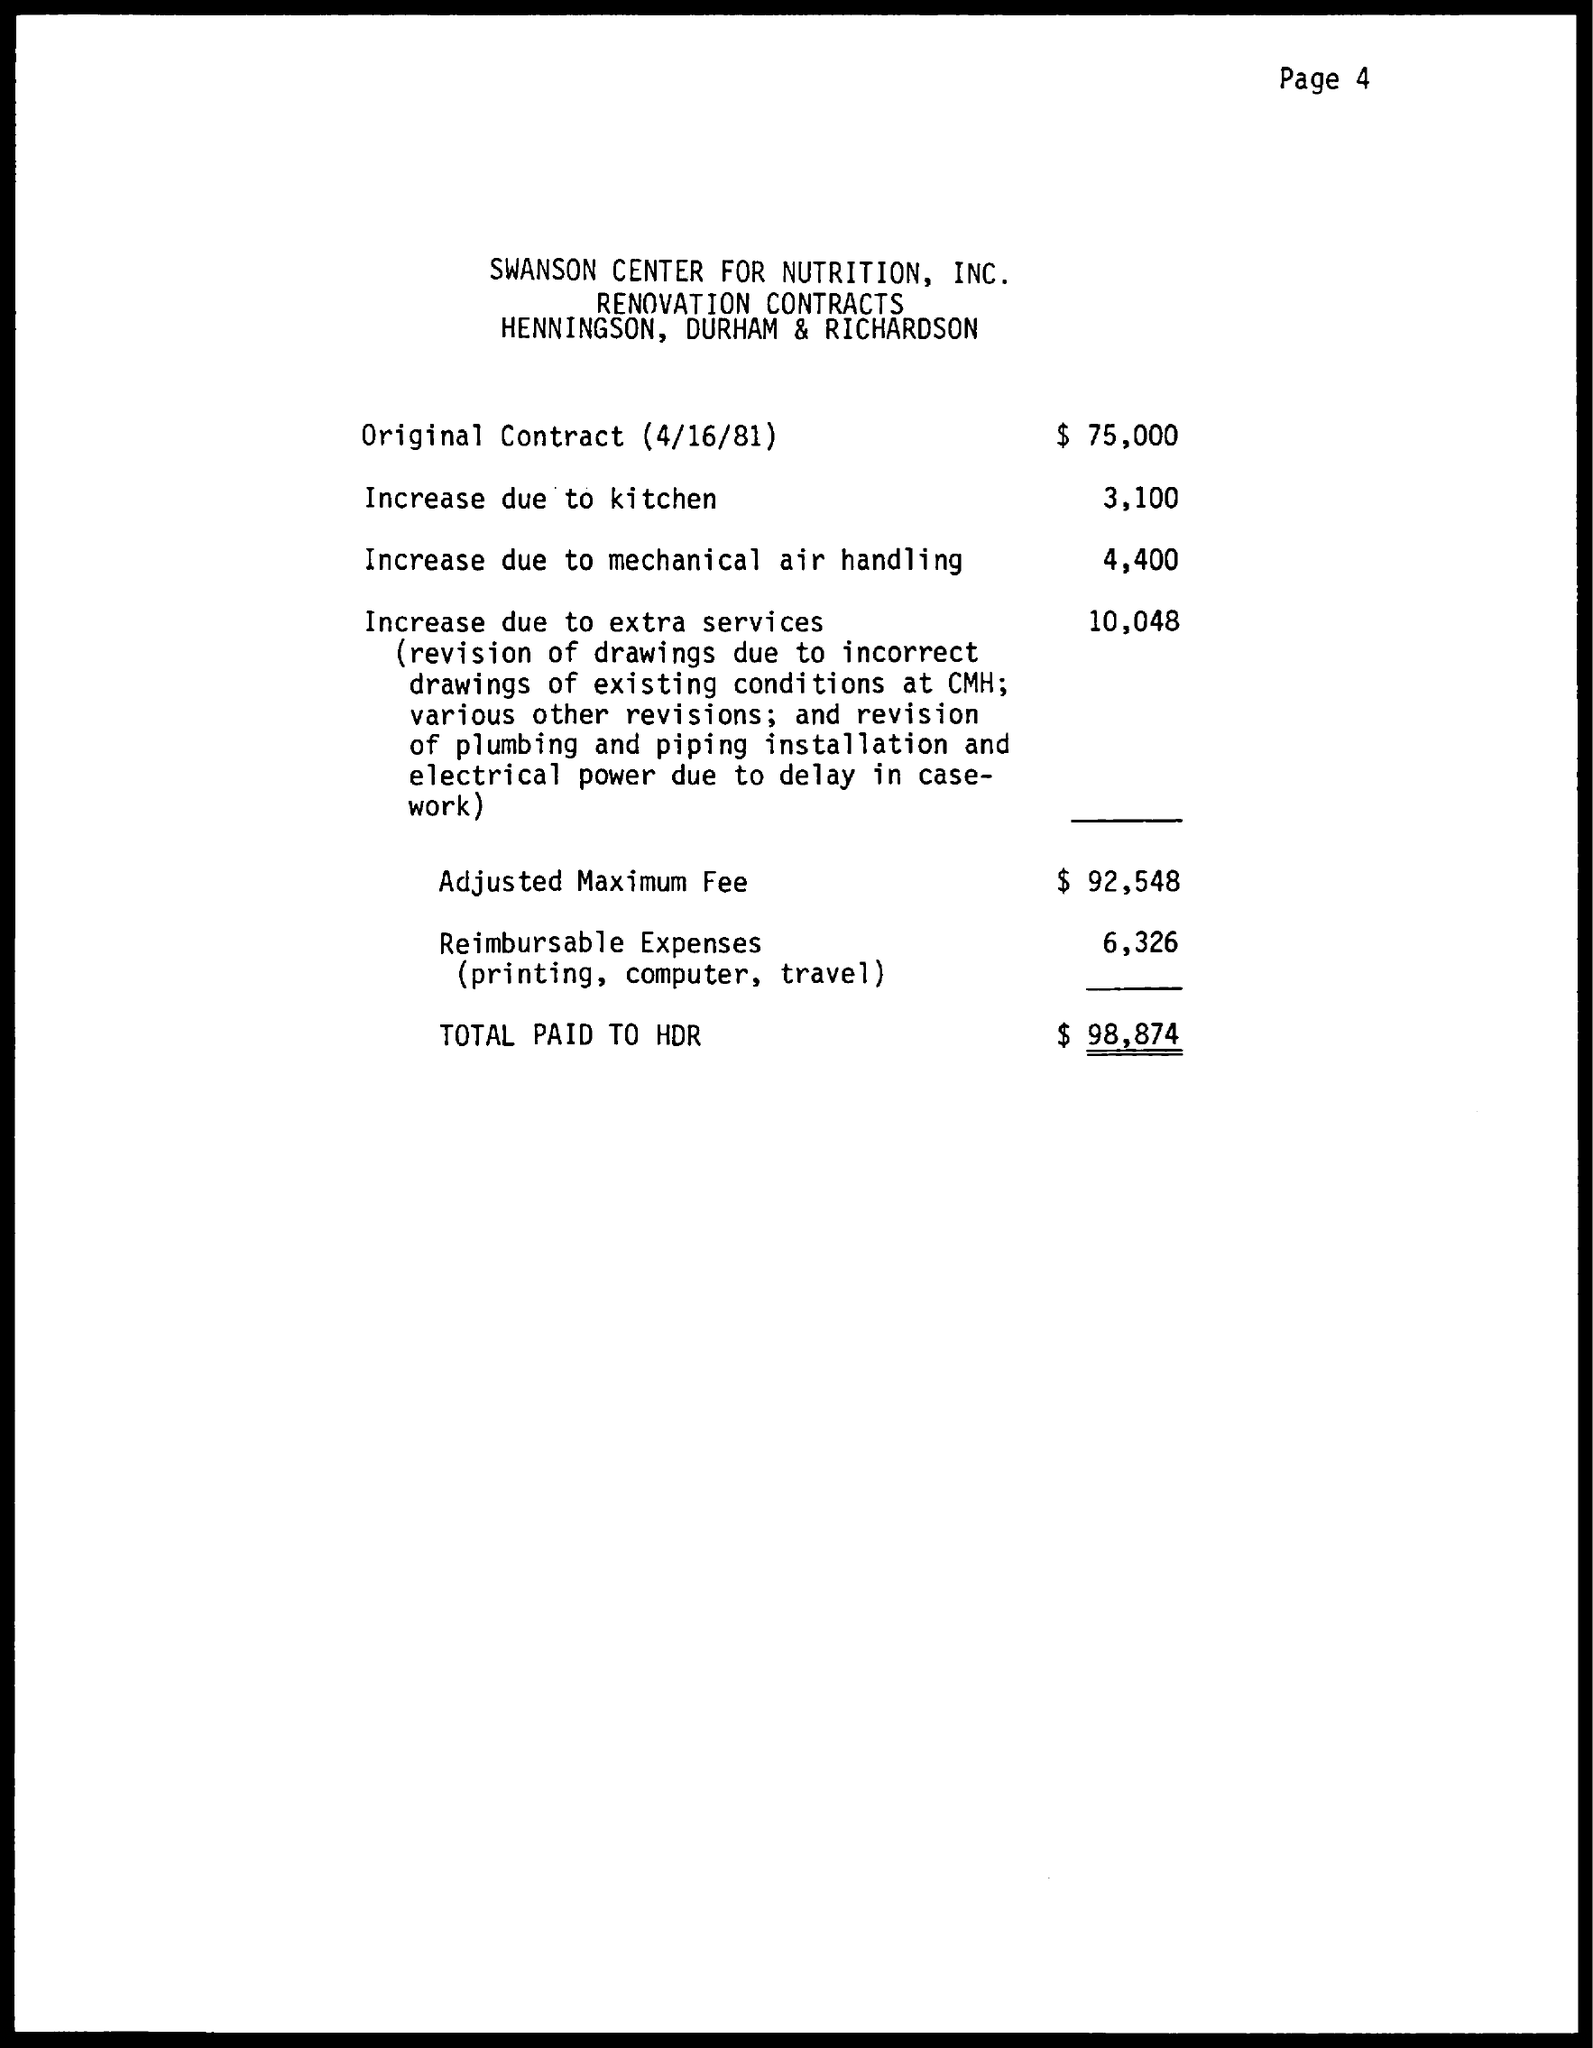Point out several critical features in this image. The total amount is $98,874. The document is titled "Swanson Center for Nutrition, Inc. The date mentioned in the document is April 16, 1981. 